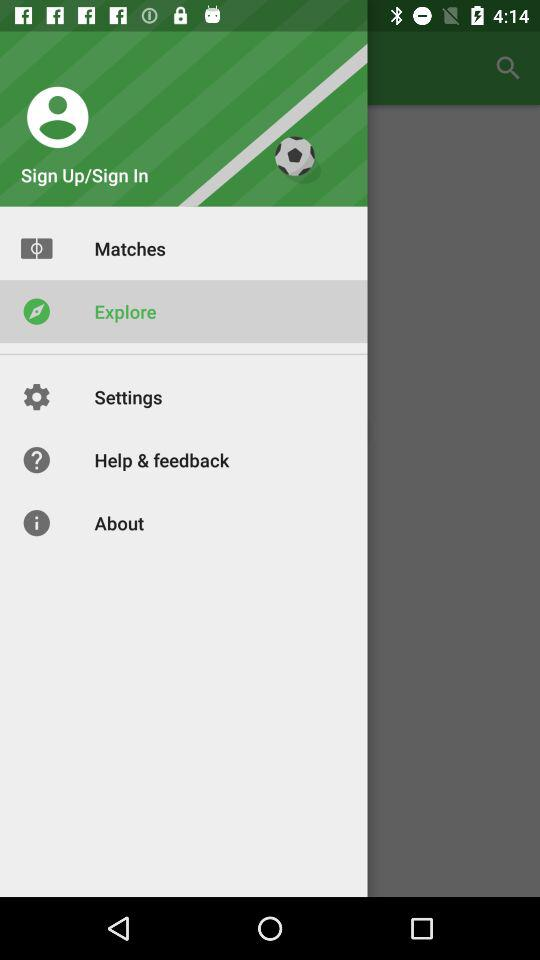What is the selected item in the menu? The selected item is "Explore". 